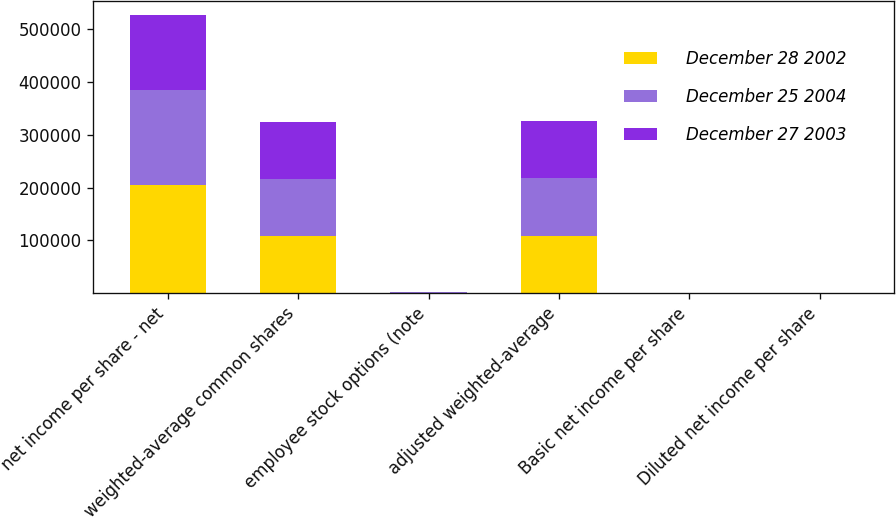Convert chart to OTSL. <chart><loc_0><loc_0><loc_500><loc_500><stacked_bar_chart><ecel><fcel>net income per share - net<fcel>weighted-average common shares<fcel>employee stock options (note<fcel>adjusted weighted-average<fcel>Basic net income per share<fcel>Diluted net income per share<nl><fcel>December 28 2002<fcel>205700<fcel>108161<fcel>869<fcel>109030<fcel>1.9<fcel>1.89<nl><fcel>December 25 2004<fcel>178634<fcel>108011<fcel>891<fcel>108902<fcel>1.65<fcel>1.64<nl><fcel>December 27 2003<fcel>142797<fcel>107774<fcel>427<fcel>108201<fcel>1.32<fcel>1.32<nl></chart> 